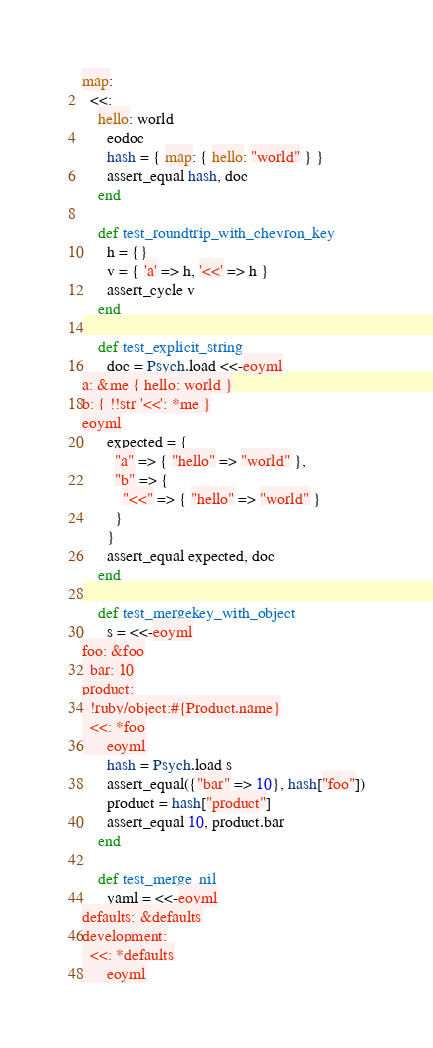Convert code to text. <code><loc_0><loc_0><loc_500><loc_500><_Ruby_>map:
  <<:
    hello: world
      eodoc
      hash = { map: { hello: "world" } }
      assert_equal hash, doc
    end

    def test_roundtrip_with_chevron_key
      h = {}
      v = { 'a' => h, '<<' => h }
      assert_cycle v
    end

    def test_explicit_string
      doc = Psych.load <<-eoyml
a: &me { hello: world }
b: { !!str '<<': *me }
eoyml
      expected = {
        "a" => { "hello" => "world" },
        "b" => {
          "<<" => { "hello" => "world" }
        }
      }
      assert_equal expected, doc
    end

    def test_mergekey_with_object
      s = <<-eoyml
foo: &foo
  bar: 10
product:
  !ruby/object:#{Product.name}
  <<: *foo
      eoyml
      hash = Psych.load s
      assert_equal({"bar" => 10}, hash["foo"])
      product = hash["product"]
      assert_equal 10, product.bar
    end

    def test_merge_nil
      yaml = <<-eoyml
defaults: &defaults
development:
  <<: *defaults
      eoyml</code> 